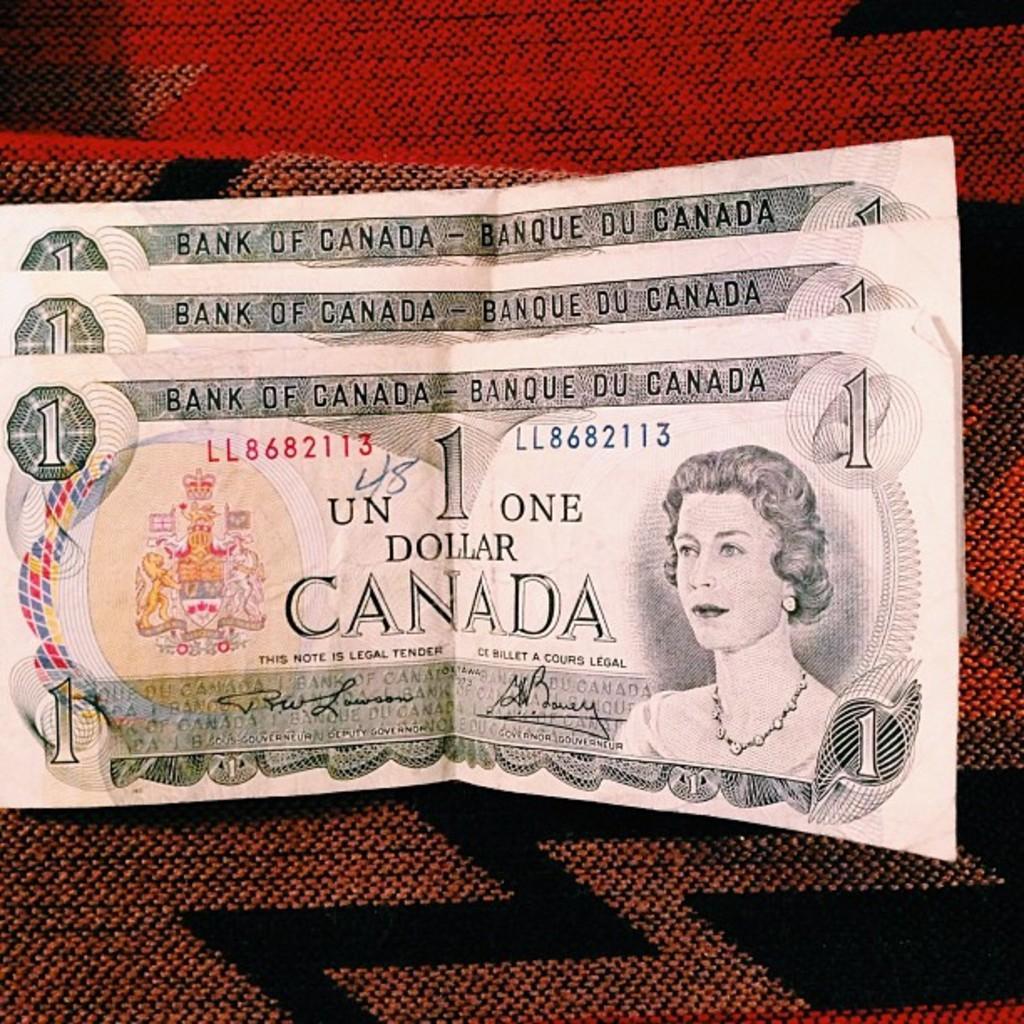Describe this image in one or two sentences. In this picture there are one dollar currency notes in the center of the image. 